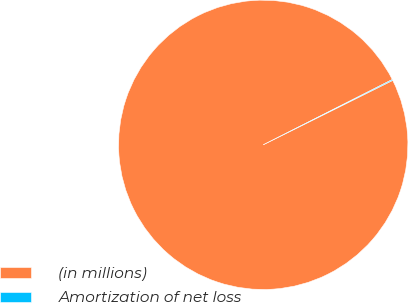<chart> <loc_0><loc_0><loc_500><loc_500><pie_chart><fcel>(in millions)<fcel>Amortization of net loss<nl><fcel>99.9%<fcel>0.1%<nl></chart> 